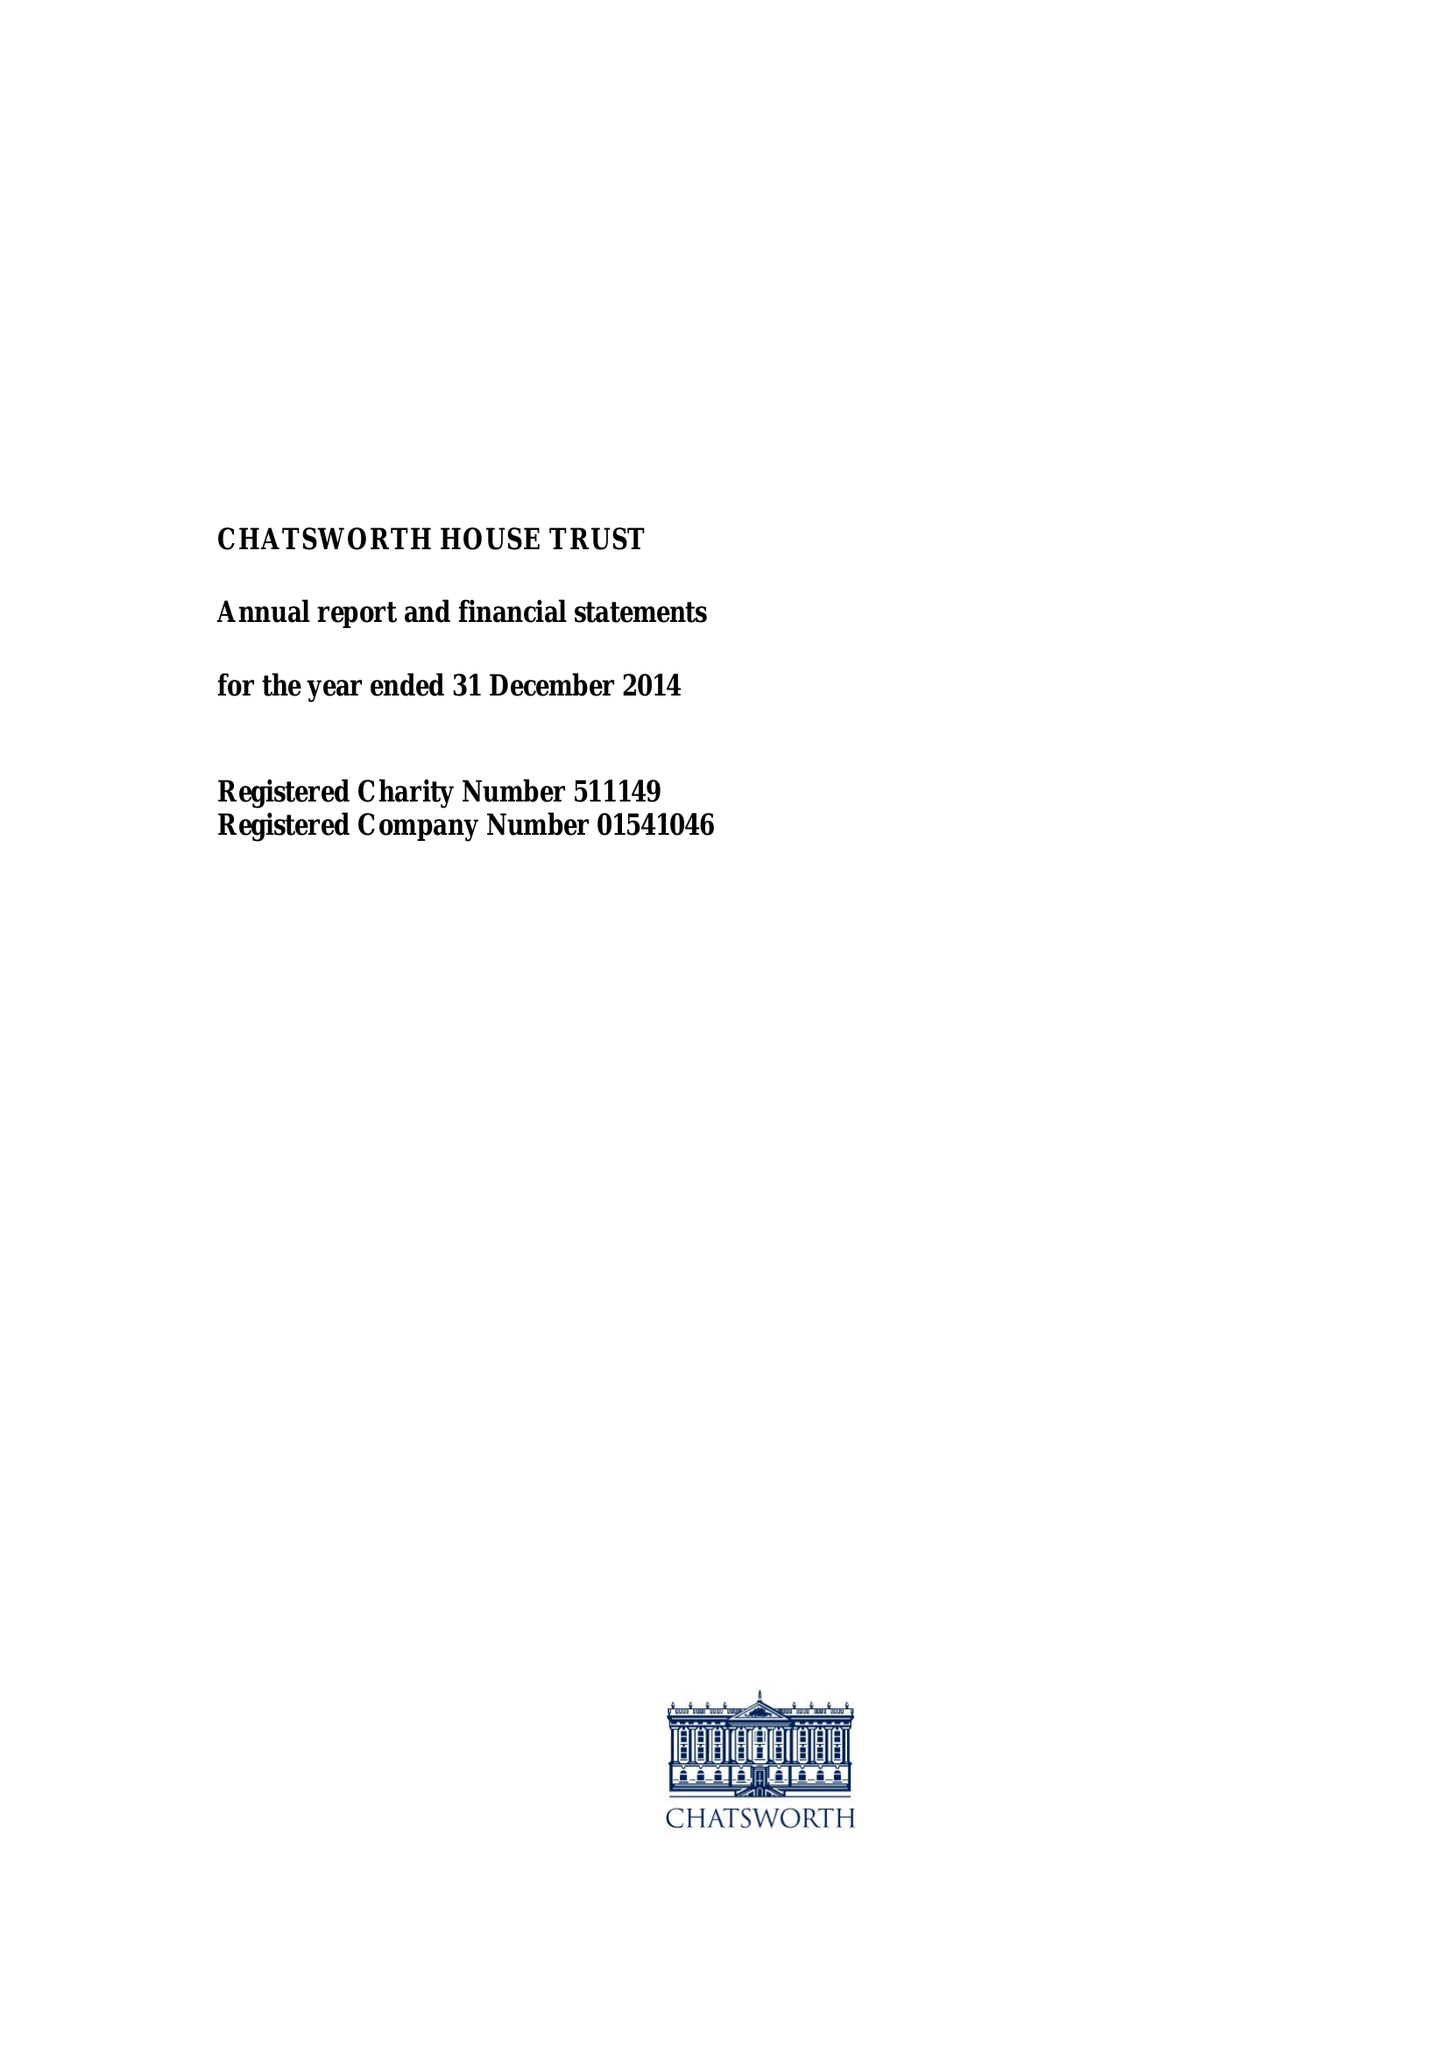What is the value for the charity_number?
Answer the question using a single word or phrase. 511149 